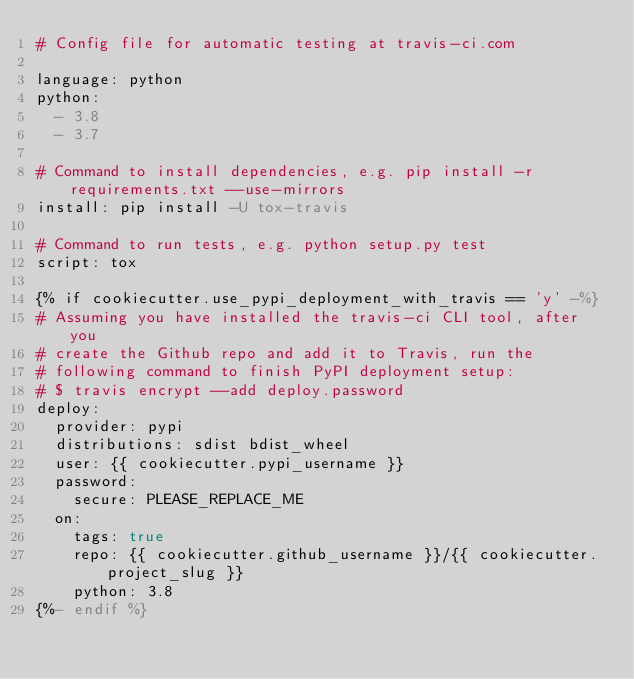<code> <loc_0><loc_0><loc_500><loc_500><_YAML_># Config file for automatic testing at travis-ci.com

language: python
python:
  - 3.8
  - 3.7

# Command to install dependencies, e.g. pip install -r requirements.txt --use-mirrors
install: pip install -U tox-travis

# Command to run tests, e.g. python setup.py test
script: tox

{% if cookiecutter.use_pypi_deployment_with_travis == 'y' -%}
# Assuming you have installed the travis-ci CLI tool, after you
# create the Github repo and add it to Travis, run the
# following command to finish PyPI deployment setup:
# $ travis encrypt --add deploy.password
deploy:
  provider: pypi
  distributions: sdist bdist_wheel
  user: {{ cookiecutter.pypi_username }}
  password:
    secure: PLEASE_REPLACE_ME
  on:
    tags: true
    repo: {{ cookiecutter.github_username }}/{{ cookiecutter.project_slug }}
    python: 3.8
{%- endif %}
</code> 